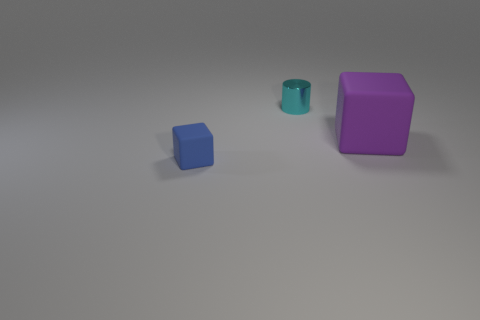Are there fewer big matte objects than large brown blocks?
Offer a very short reply. No. There is a matte cube that is left of the small metal object; how big is it?
Provide a short and direct response. Small. The thing that is to the left of the large purple thing and behind the small block has what shape?
Keep it short and to the point. Cylinder. There is another blue thing that is the same shape as the big thing; what is its size?
Make the answer very short. Small. What number of other objects are the same material as the cyan thing?
Your answer should be compact. 0. There is a large block; does it have the same color as the block that is on the left side of the large purple object?
Offer a very short reply. No. Is the number of blue cubes greater than the number of yellow cylinders?
Provide a succinct answer. Yes. The large matte block has what color?
Offer a terse response. Purple. There is a object that is right of the cylinder; does it have the same color as the small metal cylinder?
Ensure brevity in your answer.  No. How many small rubber blocks are the same color as the small rubber object?
Your answer should be very brief. 0. 